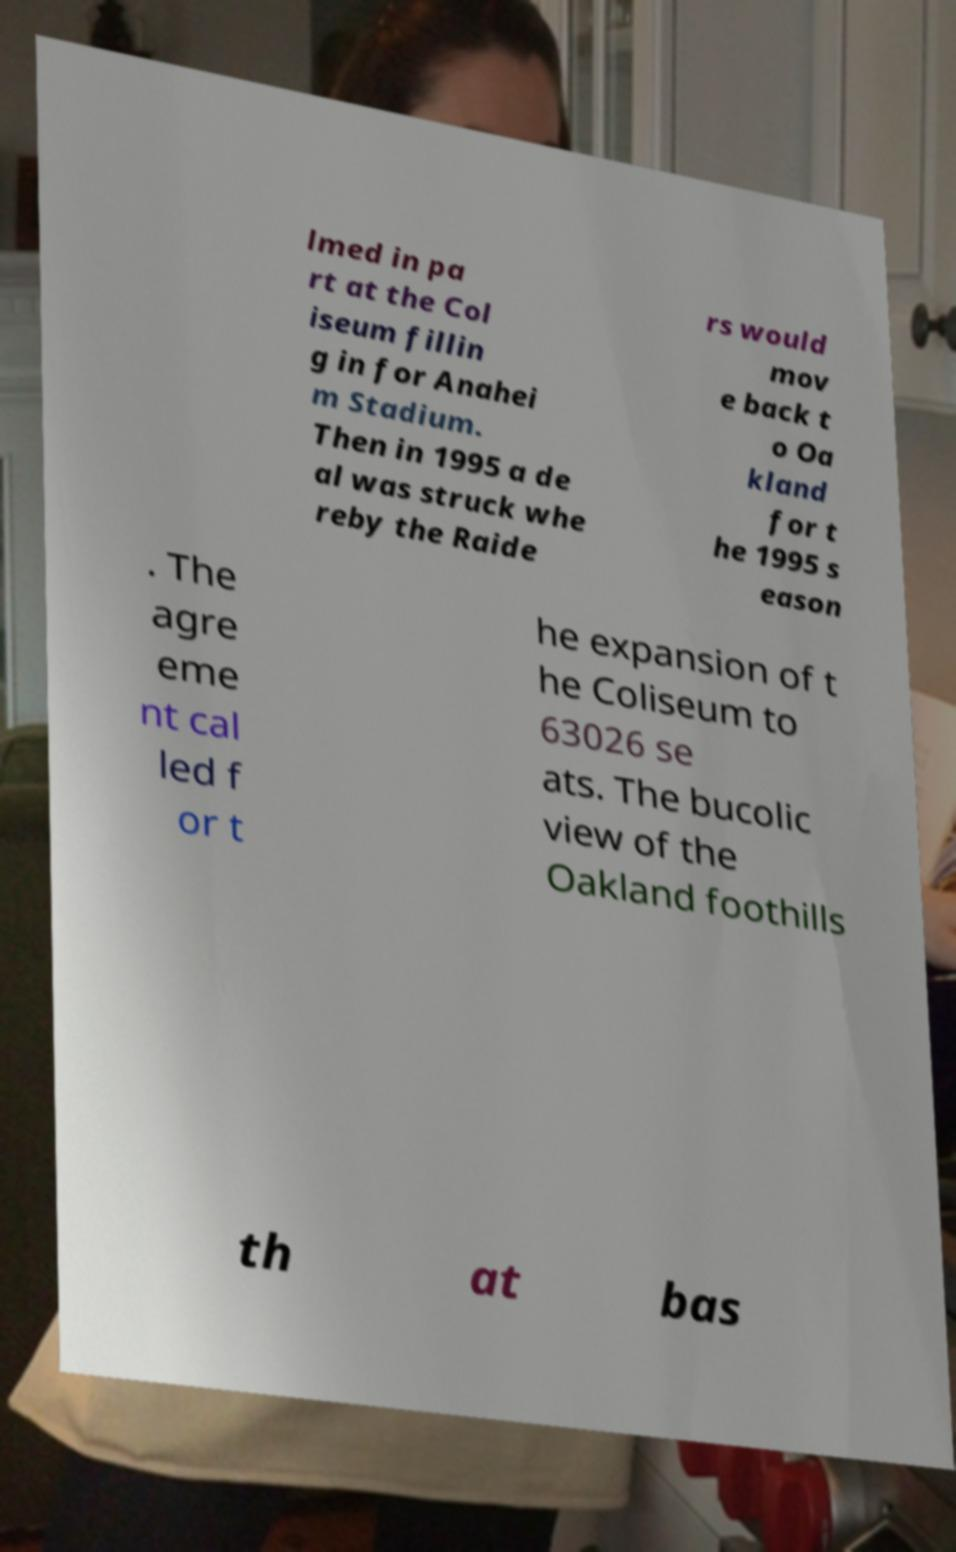Can you accurately transcribe the text from the provided image for me? lmed in pa rt at the Col iseum fillin g in for Anahei m Stadium. Then in 1995 a de al was struck whe reby the Raide rs would mov e back t o Oa kland for t he 1995 s eason . The agre eme nt cal led f or t he expansion of t he Coliseum to 63026 se ats. The bucolic view of the Oakland foothills th at bas 